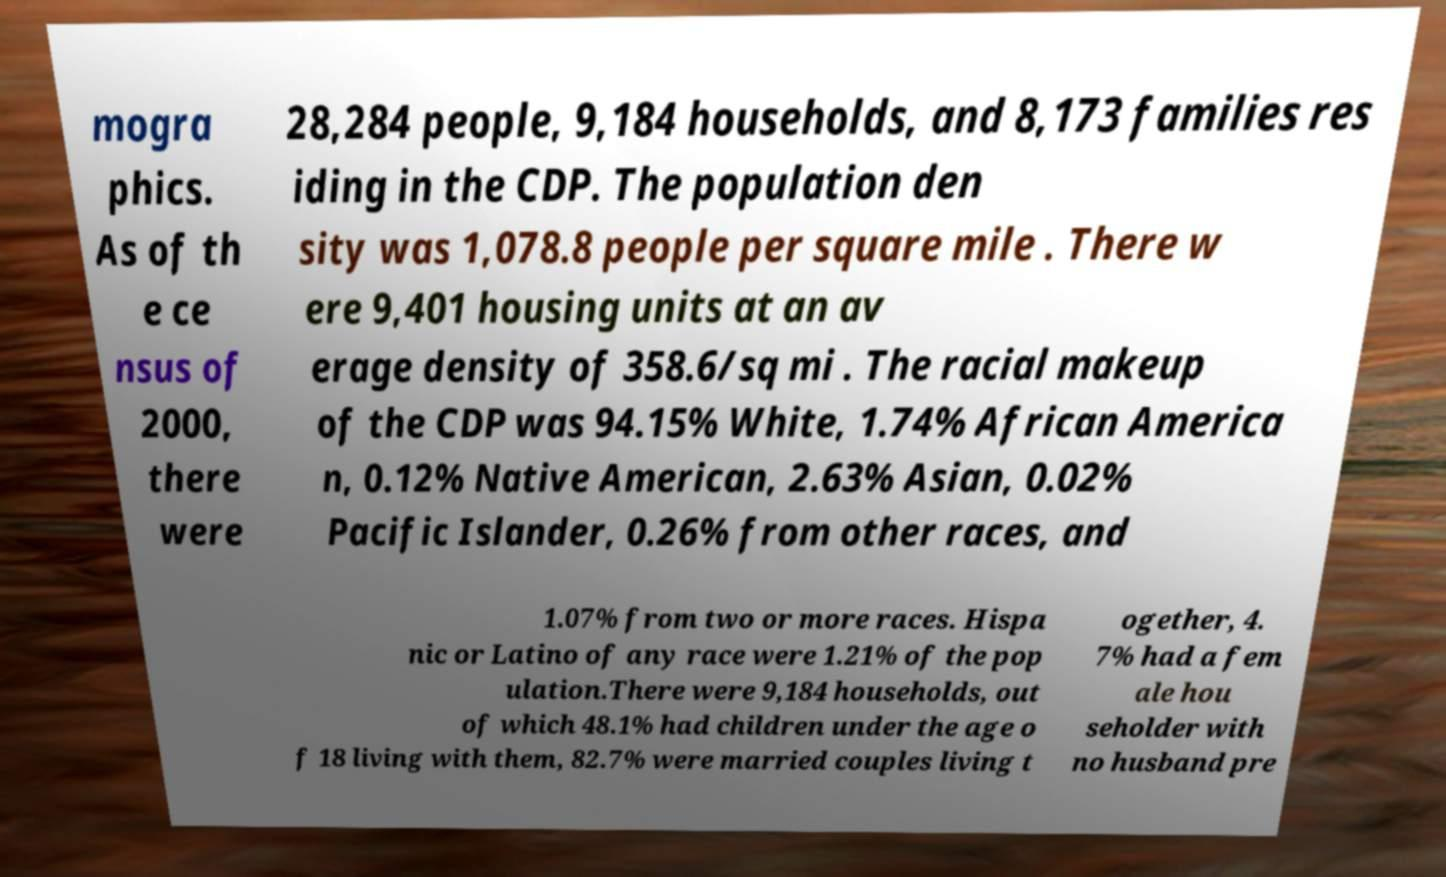Could you assist in decoding the text presented in this image and type it out clearly? mogra phics. As of th e ce nsus of 2000, there were 28,284 people, 9,184 households, and 8,173 families res iding in the CDP. The population den sity was 1,078.8 people per square mile . There w ere 9,401 housing units at an av erage density of 358.6/sq mi . The racial makeup of the CDP was 94.15% White, 1.74% African America n, 0.12% Native American, 2.63% Asian, 0.02% Pacific Islander, 0.26% from other races, and 1.07% from two or more races. Hispa nic or Latino of any race were 1.21% of the pop ulation.There were 9,184 households, out of which 48.1% had children under the age o f 18 living with them, 82.7% were married couples living t ogether, 4. 7% had a fem ale hou seholder with no husband pre 